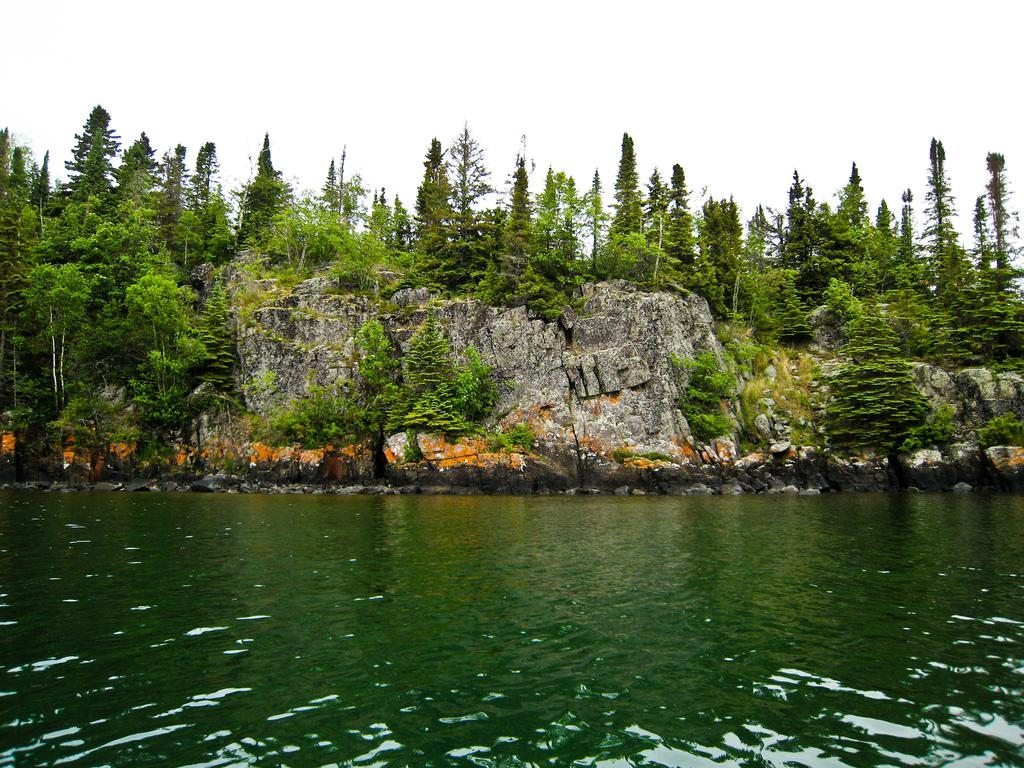What is visible in the image? Water is visible in the image. What can be seen in the background of the image? There are rocks, trees, and the sky visible in the background of the image. What type of tooth is being used to carve the wood in the image? There is no tooth or wood present in the image; it features water, rocks, trees, and the sky. 